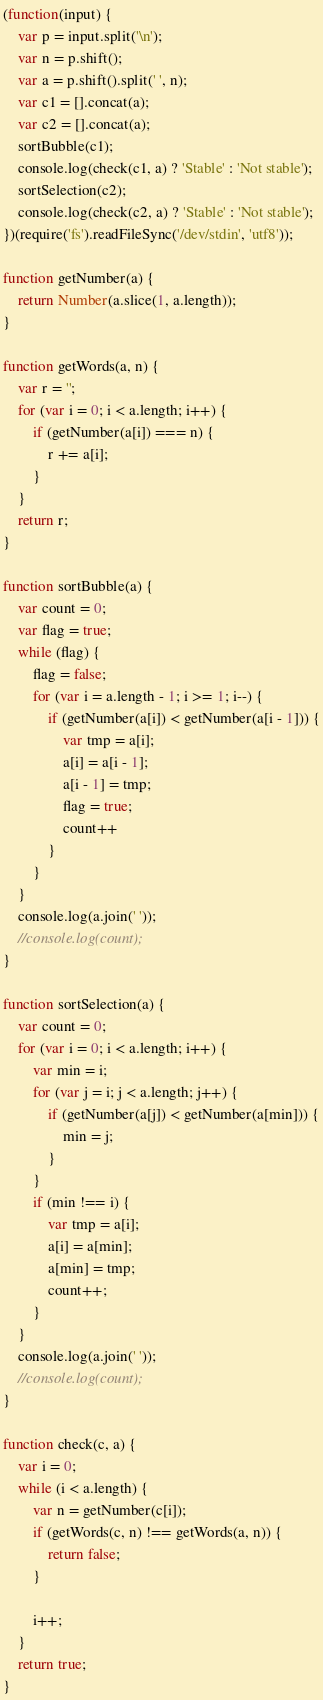<code> <loc_0><loc_0><loc_500><loc_500><_JavaScript_>(function(input) {
    var p = input.split('\n');
    var n = p.shift();
    var a = p.shift().split(' ', n);
    var c1 = [].concat(a);
    var c2 = [].concat(a);
    sortBubble(c1);
    console.log(check(c1, a) ? 'Stable' : 'Not stable');
    sortSelection(c2);
    console.log(check(c2, a) ? 'Stable' : 'Not stable');
})(require('fs').readFileSync('/dev/stdin', 'utf8'));

function getNumber(a) {
    return Number(a.slice(1, a.length));
}

function getWords(a, n) {
    var r = '';
    for (var i = 0; i < a.length; i++) {
        if (getNumber(a[i]) === n) {
            r += a[i];
        }
    }
    return r;
}

function sortBubble(a) {
    var count = 0;
    var flag = true;
    while (flag) {
        flag = false;
        for (var i = a.length - 1; i >= 1; i--) {
            if (getNumber(a[i]) < getNumber(a[i - 1])) {
                var tmp = a[i];
                a[i] = a[i - 1];
                a[i - 1] = tmp;
                flag = true;
                count++
            }
        }
    }
    console.log(a.join(' '));
    //console.log(count);
}

function sortSelection(a) {
    var count = 0;
    for (var i = 0; i < a.length; i++) {
        var min = i;
        for (var j = i; j < a.length; j++) {
            if (getNumber(a[j]) < getNumber(a[min])) {
                min = j;
            }
        }
        if (min !== i) {
            var tmp = a[i];
            a[i] = a[min];
            a[min] = tmp;
            count++;
        }
    }
    console.log(a.join(' '));
    //console.log(count);
}

function check(c, a) {
    var i = 0;
    while (i < a.length) {
        var n = getNumber(c[i]);
        if (getWords(c, n) !== getWords(a, n)) {
            return false;
        }

        i++;
    }
    return true;
}</code> 